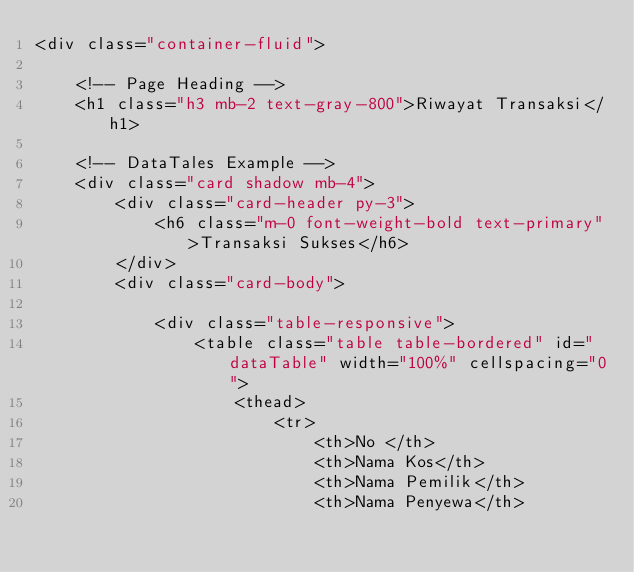<code> <loc_0><loc_0><loc_500><loc_500><_PHP_><div class="container-fluid">

    <!-- Page Heading -->
    <h1 class="h3 mb-2 text-gray-800">Riwayat Transaksi</h1>

    <!-- DataTales Example -->
    <div class="card shadow mb-4">
        <div class="card-header py-3">
            <h6 class="m-0 font-weight-bold text-primary">Transaksi Sukses</h6>
        </div>
        <div class="card-body">

            <div class="table-responsive">
                <table class="table table-bordered" id="dataTable" width="100%" cellspacing="0">
                    <thead>
                        <tr>
                            <th>No </th>
                            <th>Nama Kos</th>
                            <th>Nama Pemilik</th>
                            <th>Nama Penyewa</th></code> 